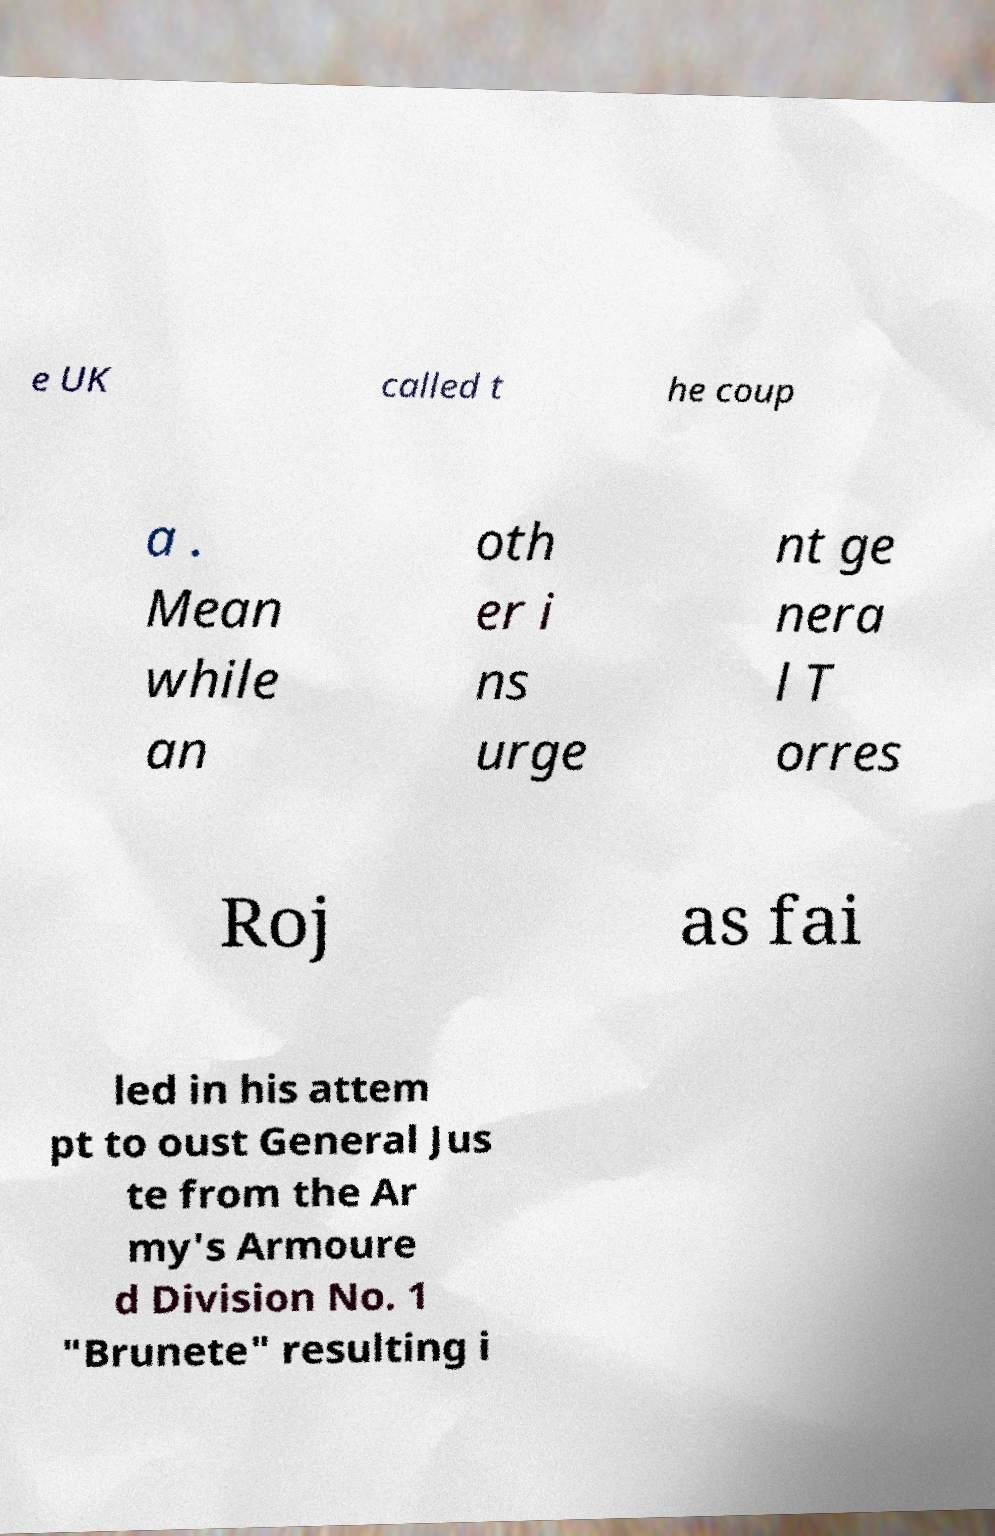For documentation purposes, I need the text within this image transcribed. Could you provide that? e UK called t he coup a . Mean while an oth er i ns urge nt ge nera l T orres Roj as fai led in his attem pt to oust General Jus te from the Ar my's Armoure d Division No. 1 "Brunete" resulting i 